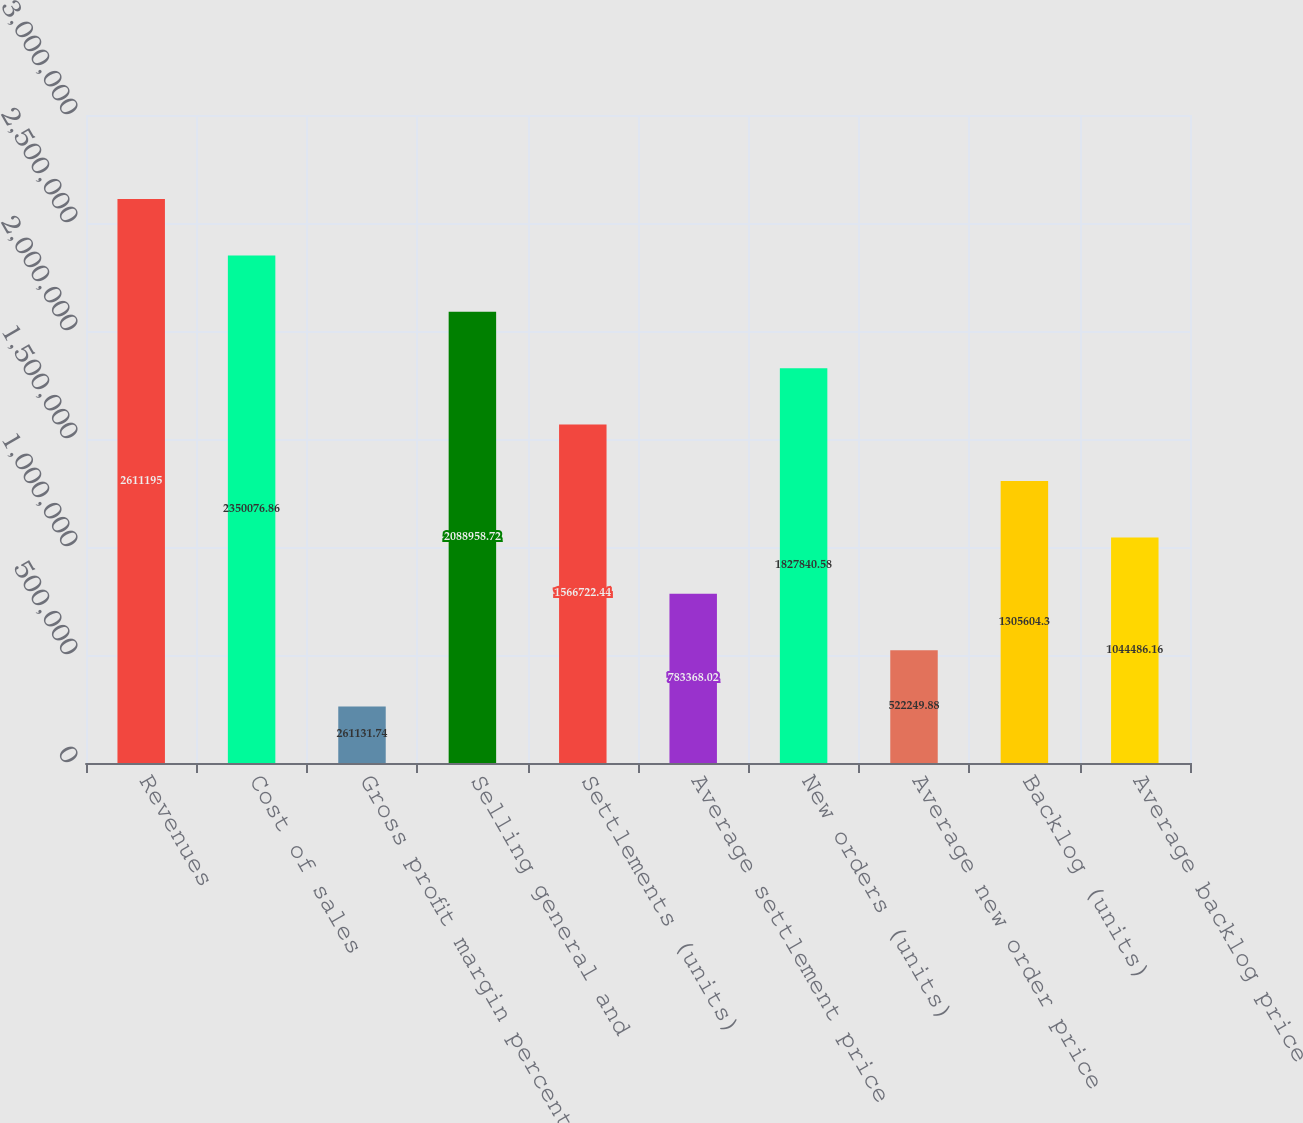<chart> <loc_0><loc_0><loc_500><loc_500><bar_chart><fcel>Revenues<fcel>Cost of sales<fcel>Gross profit margin percentage<fcel>Selling general and<fcel>Settlements (units)<fcel>Average settlement price<fcel>New orders (units)<fcel>Average new order price<fcel>Backlog (units)<fcel>Average backlog price<nl><fcel>2.6112e+06<fcel>2.35008e+06<fcel>261132<fcel>2.08896e+06<fcel>1.56672e+06<fcel>783368<fcel>1.82784e+06<fcel>522250<fcel>1.3056e+06<fcel>1.04449e+06<nl></chart> 